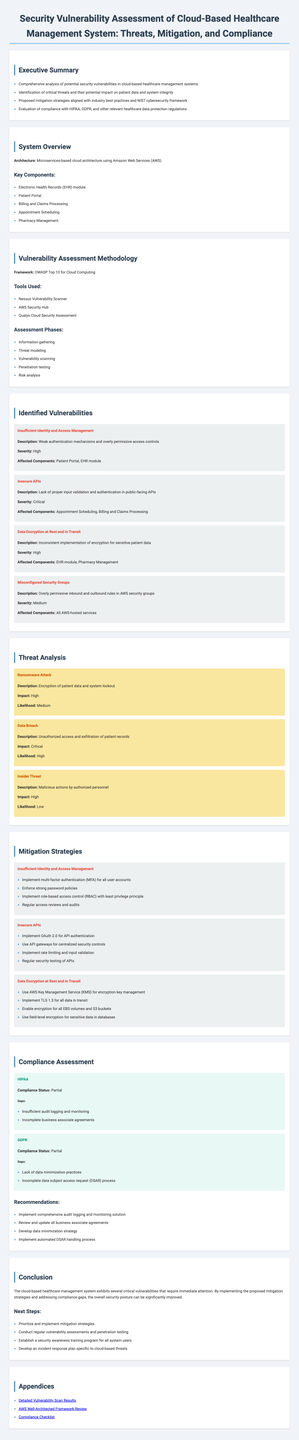What is the title of the report? The title of the report is stated at the top and summarizes the content.
Answer: Security Vulnerability Assessment of Cloud-Based Healthcare Management System: Threats, Mitigation, and Compliance What framework was used for the vulnerability assessment? The framework for the vulnerability assessment is mentioned under the methodology section.
Answer: OWASP Top 10 for Cloud Computing How many vulnerabilities were identified? The number of identified vulnerabilities can be counted from the section listing them.
Answer: Four What is the compliance status for HIPAA? The compliance status is clearly listed next to the regulation name.
Answer: Partial What severity level is assigned to insecure APIs? The severity level is stated in the description of the identified vulnerabilities.
Answer: Critical What risk is associated with a ransomware attack? Risks are categorized in terms of impact and likelihood.
Answer: High Which component is affected by insufficient identity and access management? Affected components are listed with each vulnerability description.
Answer: Patient Portal, EHR module What does the recommendation for data encryption include? Recommendations are provided for each identified vulnerability; the focus is on encryption.
Answer: Use AWS Key Management Service (KMS) for encryption key management What is one of the gaps in the GDPR compliance status? Gaps in compliance are specifically mentioned under each regulation.
Answer: Lack of data minimization practices 